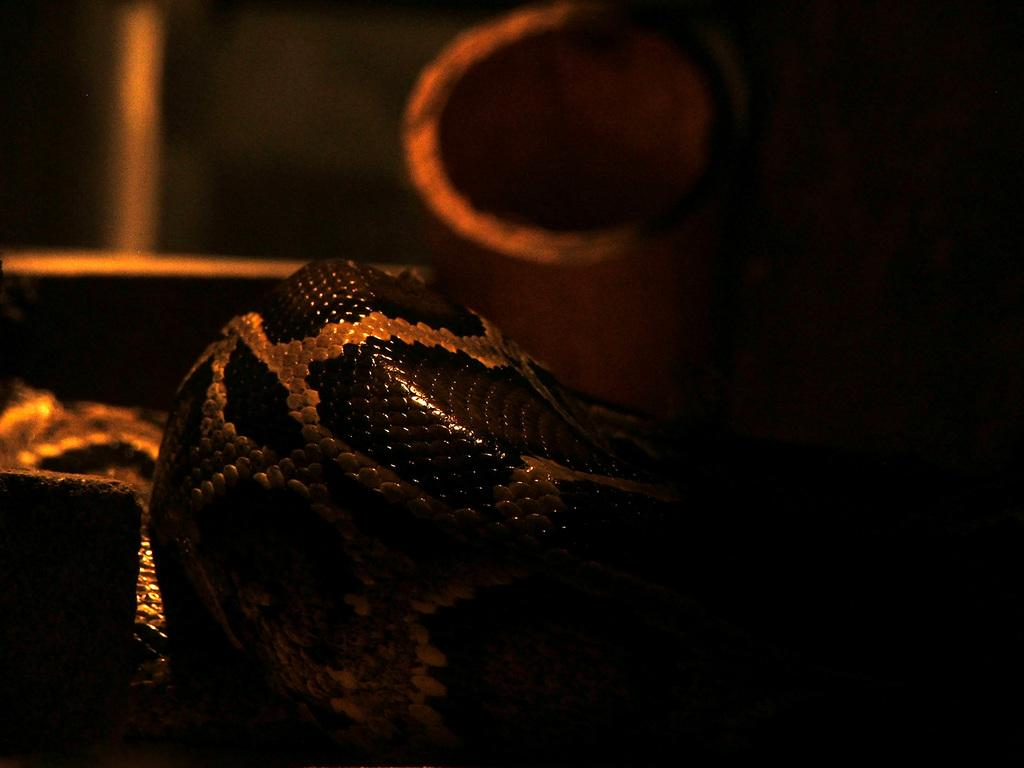What is the main subject in the center of the image? There is a snake in the center of the image. What can be seen on the left side of the image? There is an object on the left side of the image. How would you describe the background of the image? The background of the image is blurred. How many stamps are on the snake in the image? There are no stamps present on the snake in the image. What type of dog can be seen interacting with the snake in the image? There is no dog present in the image; it only features a snake and an object on the left side. 